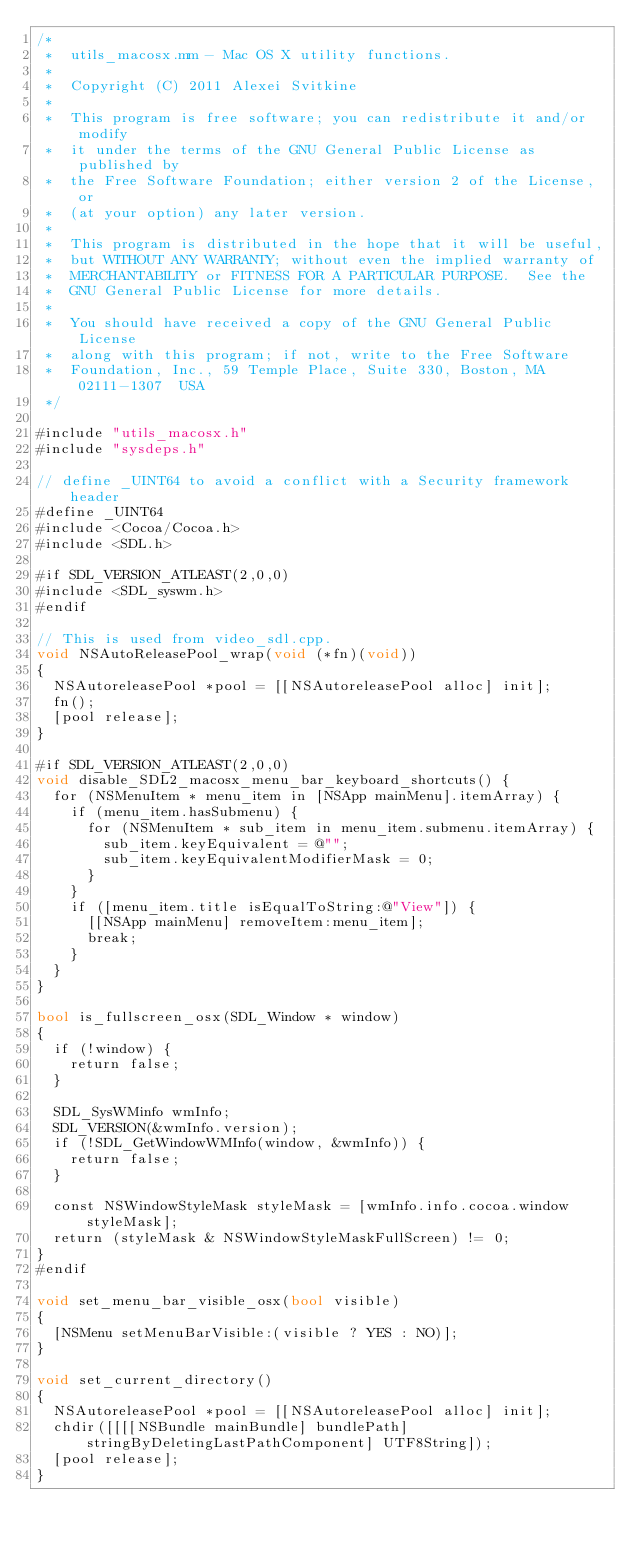<code> <loc_0><loc_0><loc_500><loc_500><_ObjectiveC_>/*
 *	utils_macosx.mm - Mac OS X utility functions.
 *
 *  Copyright (C) 2011 Alexei Svitkine
 *
 *  This program is free software; you can redistribute it and/or modify
 *  it under the terms of the GNU General Public License as published by
 *  the Free Software Foundation; either version 2 of the License, or
 *  (at your option) any later version.
 *
 *  This program is distributed in the hope that it will be useful,
 *  but WITHOUT ANY WARRANTY; without even the implied warranty of
 *  MERCHANTABILITY or FITNESS FOR A PARTICULAR PURPOSE.  See the
 *  GNU General Public License for more details.
 *
 *  You should have received a copy of the GNU General Public License
 *  along with this program; if not, write to the Free Software
 *  Foundation, Inc., 59 Temple Place, Suite 330, Boston, MA  02111-1307  USA
 */

#include "utils_macosx.h"
#include "sysdeps.h"

// define _UINT64 to avoid a conflict with a Security framework header
#define _UINT64
#include <Cocoa/Cocoa.h>
#include <SDL.h>

#if SDL_VERSION_ATLEAST(2,0,0)
#include <SDL_syswm.h>
#endif

// This is used from video_sdl.cpp.
void NSAutoReleasePool_wrap(void (*fn)(void))
{
	NSAutoreleasePool *pool = [[NSAutoreleasePool alloc] init];
	fn();
	[pool release];
}

#if SDL_VERSION_ATLEAST(2,0,0)
void disable_SDL2_macosx_menu_bar_keyboard_shortcuts() {
	for (NSMenuItem * menu_item in [NSApp mainMenu].itemArray) {
		if (menu_item.hasSubmenu) {
			for (NSMenuItem * sub_item in menu_item.submenu.itemArray) {
				sub_item.keyEquivalent = @"";
				sub_item.keyEquivalentModifierMask = 0;
			}
		}
		if ([menu_item.title isEqualToString:@"View"]) {
			[[NSApp mainMenu] removeItem:menu_item];
			break;
		}
	}
}

bool is_fullscreen_osx(SDL_Window * window)
{
	if (!window) {
		return false;
	}
	
	SDL_SysWMinfo wmInfo;
	SDL_VERSION(&wmInfo.version);
	if (!SDL_GetWindowWMInfo(window, &wmInfo)) {
		return false;
	}

	const NSWindowStyleMask styleMask = [wmInfo.info.cocoa.window styleMask];
	return (styleMask & NSWindowStyleMaskFullScreen) != 0;
}
#endif

void set_menu_bar_visible_osx(bool visible)
{
	[NSMenu setMenuBarVisible:(visible ? YES : NO)];
}

void set_current_directory()
{
	NSAutoreleasePool *pool = [[NSAutoreleasePool alloc] init];
	chdir([[[[NSBundle mainBundle] bundlePath] stringByDeletingLastPathComponent] UTF8String]);
	[pool release];
}

</code> 